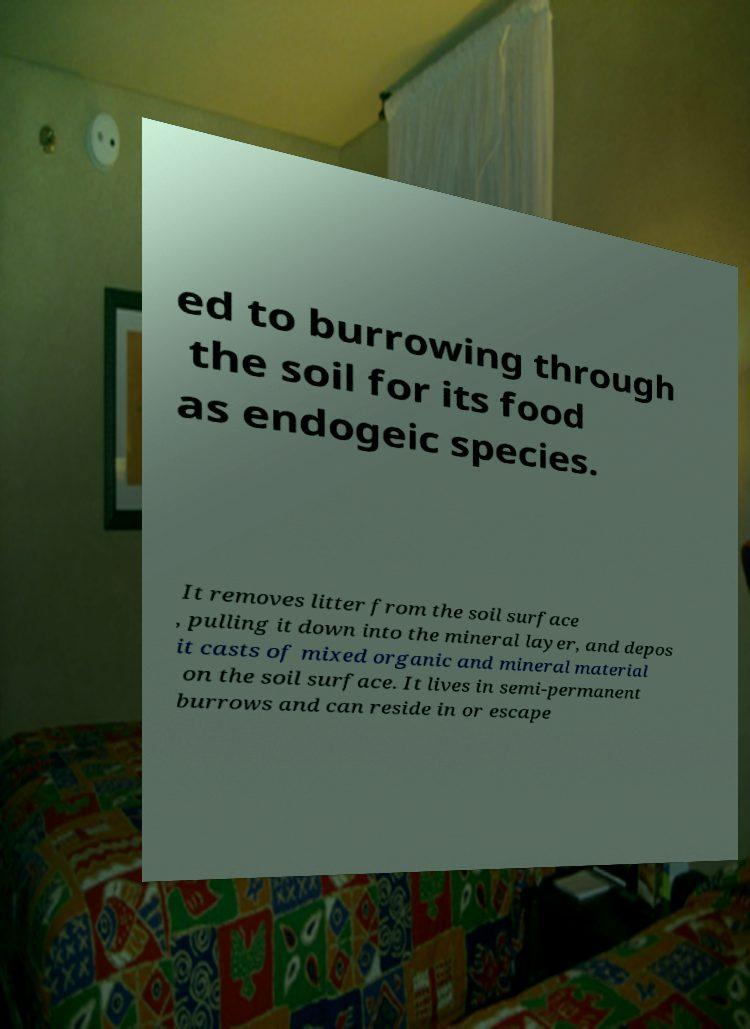Can you accurately transcribe the text from the provided image for me? ed to burrowing through the soil for its food as endogeic species. It removes litter from the soil surface , pulling it down into the mineral layer, and depos it casts of mixed organic and mineral material on the soil surface. It lives in semi-permanent burrows and can reside in or escape 